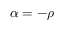Convert formula to latex. <formula><loc_0><loc_0><loc_500><loc_500>\alpha = - \rho</formula> 